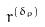<formula> <loc_0><loc_0><loc_500><loc_500>r ^ { ( \delta _ { \rho } ) }</formula> 